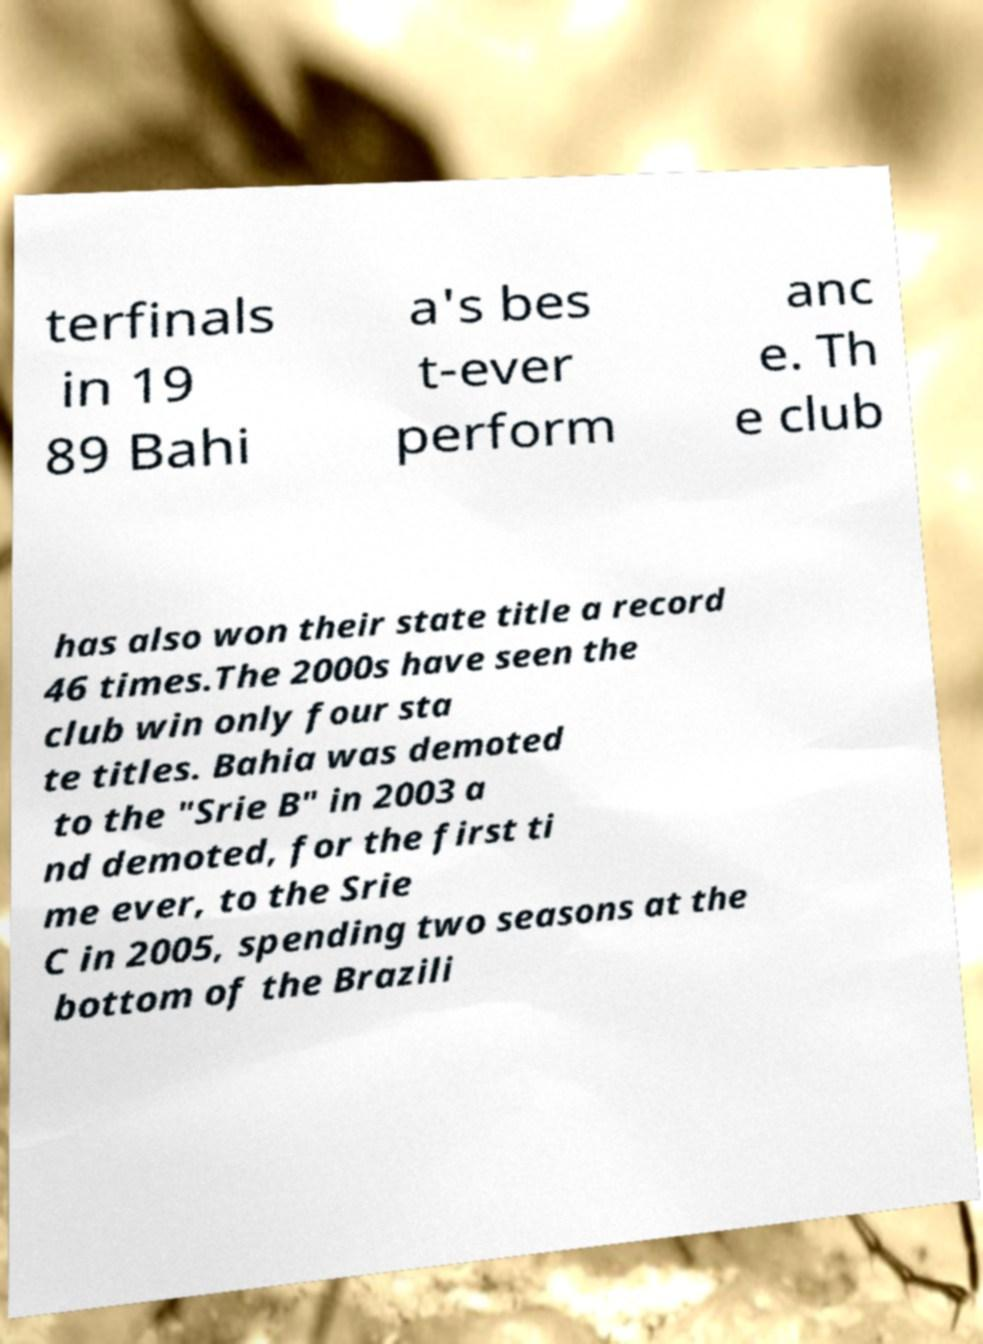Could you assist in decoding the text presented in this image and type it out clearly? terfinals in 19 89 Bahi a's bes t-ever perform anc e. Th e club has also won their state title a record 46 times.The 2000s have seen the club win only four sta te titles. Bahia was demoted to the "Srie B" in 2003 a nd demoted, for the first ti me ever, to the Srie C in 2005, spending two seasons at the bottom of the Brazili 